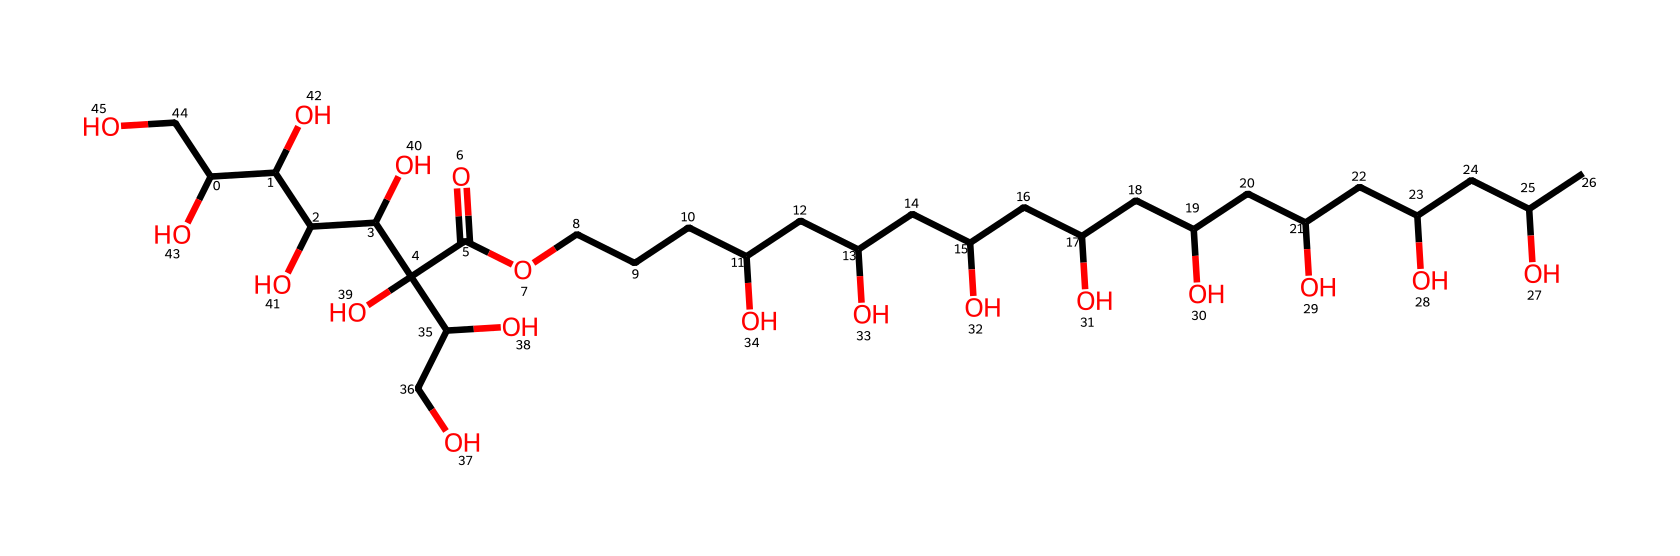What is the main functional group present in polysorbate 20? The main functional group in polysorbate 20 is a carboxylic acid group, which can be identified by the presence of the -COOH structure in the molecule.
Answer: carboxylic acid How many carbon atoms are present in polysorbate 20? By counting the carbon atoms in the provided SMILES representation, we can identify that there are 20 carbon atoms in total counted across the entire structure.
Answer: 20 What type of surfactant is polysorbate 20? Polysorbate 20 is classified as a nonionic surfactant due to the absence of ionic groups (like -NH3 or -COO-), which is a characteristic of nonionic surfactants.
Answer: nonionic What is the total number of hydroxyl (–OH) groups in polysorbate 20? By analyzing the structure, we can see that there are 12 hydroxyl groups present as indicated by the multiple -OH groups scattered throughout the compound.
Answer: 12 Which part of polysorbate 20 contributes to its emulsifying properties? The hydrophilic portion, which includes the numerous hydroxyl groups and the ethylene oxide units, is responsible for the emulsifying properties given their ability to interact with both hydrophobic and hydrophilic parts of mixtures.
Answer: hydrophilic portion What is the molecular weight range of polysorbate 20? The molecular weight can be estimated based on the structure, typically falling within a range that is characteristic for polysorbates, which is around 1,000 to 1,300 grams per mole for polysorbate 20.
Answer: 1,000 to 1,300 